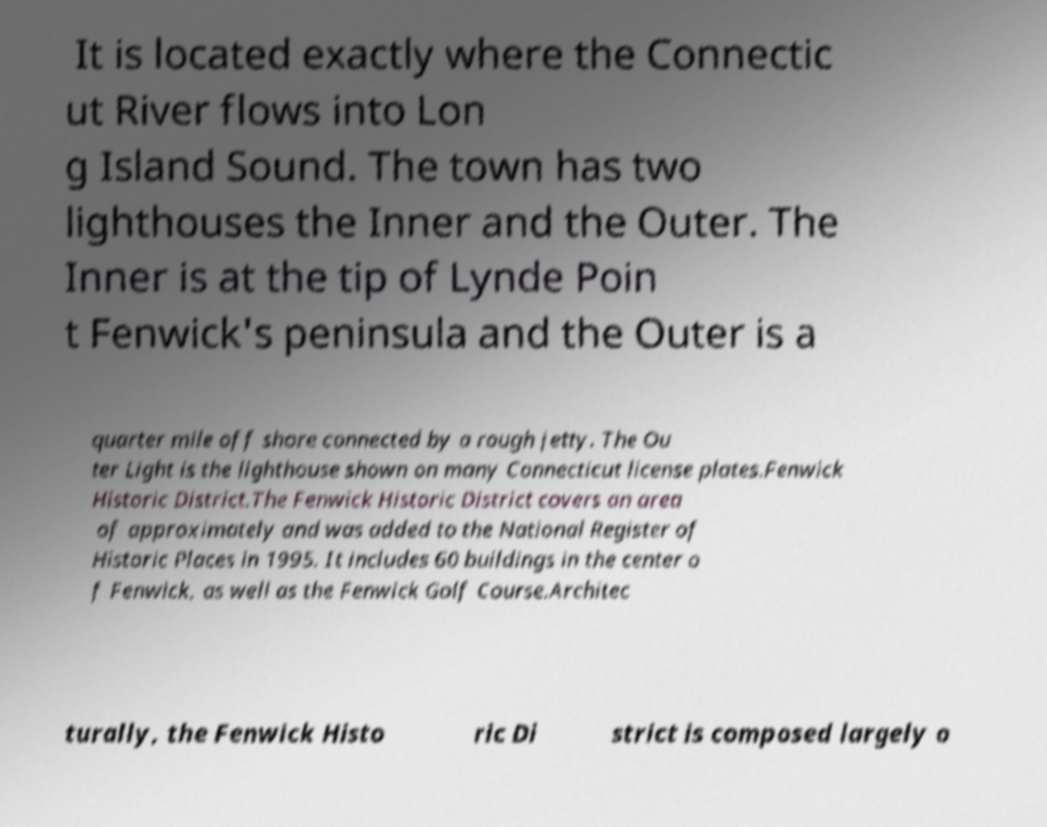Please identify and transcribe the text found in this image. It is located exactly where the Connectic ut River flows into Lon g Island Sound. The town has two lighthouses the Inner and the Outer. The Inner is at the tip of Lynde Poin t Fenwick's peninsula and the Outer is a quarter mile off shore connected by a rough jetty. The Ou ter Light is the lighthouse shown on many Connecticut license plates.Fenwick Historic District.The Fenwick Historic District covers an area of approximately and was added to the National Register of Historic Places in 1995. It includes 60 buildings in the center o f Fenwick, as well as the Fenwick Golf Course.Architec turally, the Fenwick Histo ric Di strict is composed largely o 